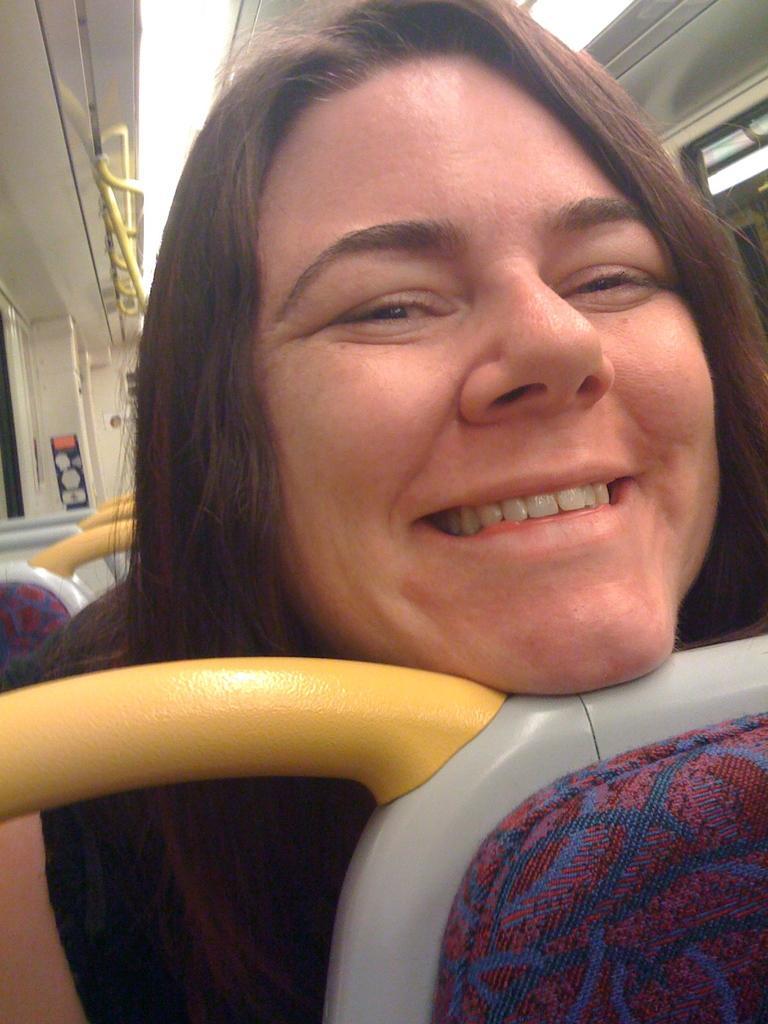In one or two sentences, can you explain what this image depicts? It is the image of a woman, she is keeping her head on a seat in a vehicle and she is smiling. 